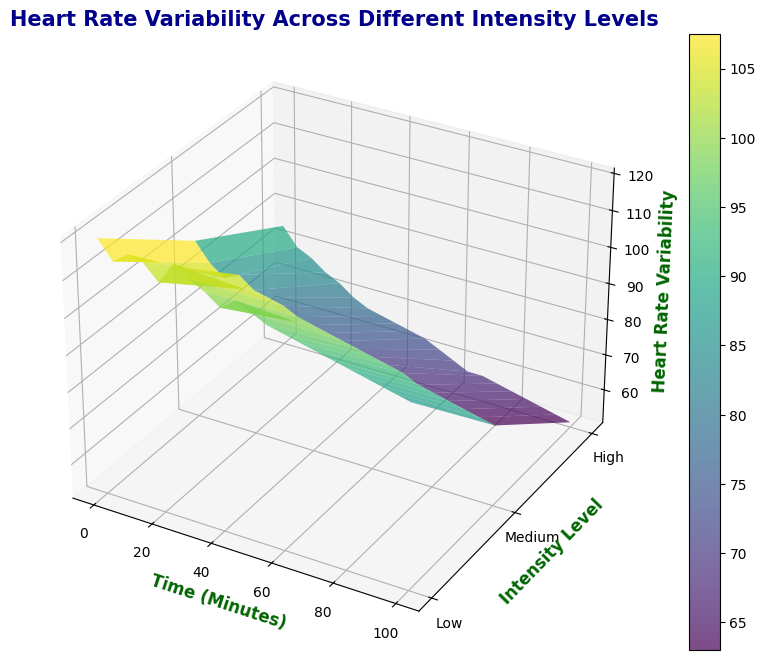What's the trend of heart rate variability over time for high-intensity level? Heart rate variability at high intensity decreases steadily over time. Initially, it starts at around 85 at 0 minutes and drops to approximately 52 by 100 minutes.
Answer: It decreases steadily Between which intensity levels is the difference in heart rate variability the greatest at the 30-minute mark? At 30 minutes, the heart rate variability for low intensity is 116, for medium intensity is 89, and for high intensity is 68. The difference between low and high intensities is 48, which is the greatest.
Answer: Between low and high intensities What is the average heart rate variability for low intensity between 0 to 20 minutes? For low intensity from 0 to 20 minutes, the heart rate variability values are 120, 115, 118, 117, 113. Summing these values gives 583, and dividing by the number of data points (5) gives an average of 116.6.
Answer: 116.6 Which intensity level has the lowest heart rate variability at the end of the workout (100 minutes)? At 100 minutes, the heart rate variability is 101 for low intensity, 73 for medium intensity, and 52 for high intensity. The lowest is 52 for high intensity.
Answer: High intensity At the 45-minute mark, how does the heart rate variability compare across different intensity levels? At 45 minutes, the heart rate variability values are 114 for low intensity, 85 for medium intensity, and 65 for high intensity. Low intensity has the highest value, followed by medium, and high intensity has the lowest.
Answer: Low > Medium > High What color represents the highest heart rate variability on the surface plot? In the 3D plot with viridis colormap, the highest heart rate variability is usually represented by shades of yellow. So yellow represents the highest values.
Answer: Yellow What is the heart rate variability for medium intensity at the 55-minute mark? At 55 minutes, the heart rate variability for medium intensity is 83 as indicated in the dataset.
Answer: 83 How does heart rate variability change for medium intensity from 0 to 100 minutes? For medium intensity, heart rate variability decreases from 100 at 0 minutes to 73 at 100 minutes. The decline appears somewhat steady over time.
Answer: It decreases steadily What is the difference in heart rate variability between low and medium intensity levels at 85 minutes? At 85 minutes, the heart rate variability is 104 for low intensity and 76 for medium intensity. The difference is 104 - 76 = 28.
Answer: 28 